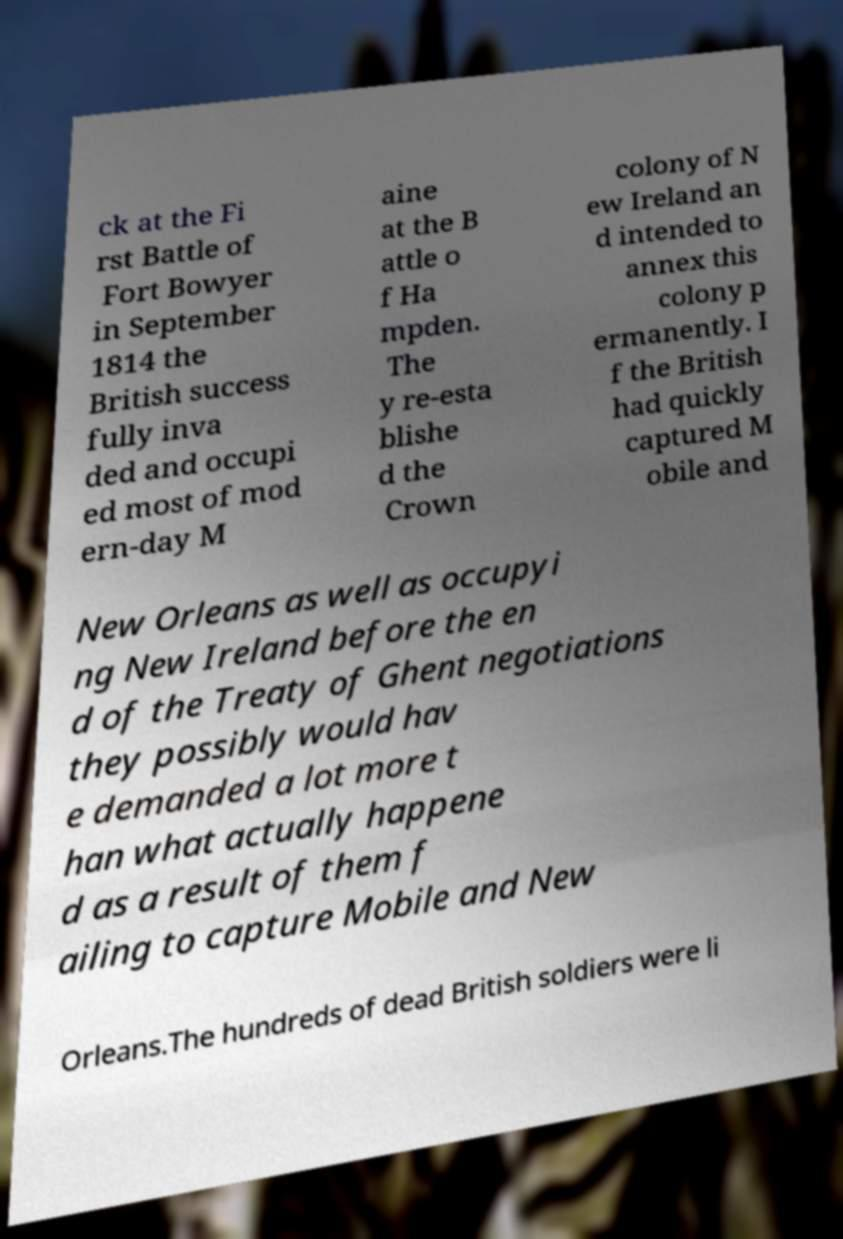Can you accurately transcribe the text from the provided image for me? ck at the Fi rst Battle of Fort Bowyer in September 1814 the British success fully inva ded and occupi ed most of mod ern-day M aine at the B attle o f Ha mpden. The y re-esta blishe d the Crown colony of N ew Ireland an d intended to annex this colony p ermanently. I f the British had quickly captured M obile and New Orleans as well as occupyi ng New Ireland before the en d of the Treaty of Ghent negotiations they possibly would hav e demanded a lot more t han what actually happene d as a result of them f ailing to capture Mobile and New Orleans.The hundreds of dead British soldiers were li 